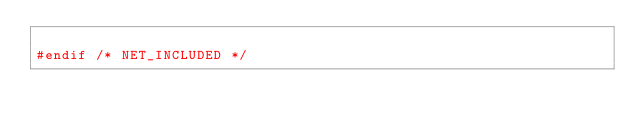<code> <loc_0><loc_0><loc_500><loc_500><_C_>
#endif /* NET_INCLUDED */
</code> 